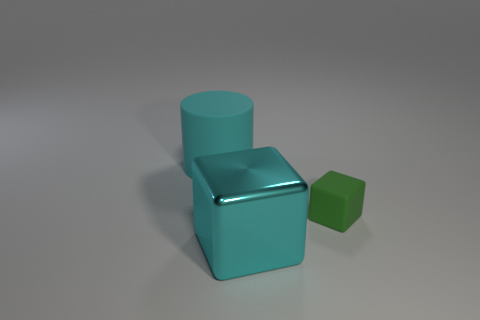Add 3 small red cubes. How many objects exist? 6 Add 3 rubber objects. How many rubber objects exist? 5 Subtract 0 red cylinders. How many objects are left? 3 Subtract all cylinders. How many objects are left? 2 Subtract 2 cubes. How many cubes are left? 0 Subtract all yellow cylinders. Subtract all blue spheres. How many cylinders are left? 1 Subtract all blue balls. How many blue cylinders are left? 0 Subtract all small green metallic blocks. Subtract all cyan objects. How many objects are left? 1 Add 1 large cylinders. How many large cylinders are left? 2 